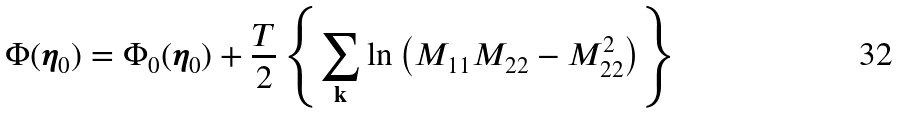Convert formula to latex. <formula><loc_0><loc_0><loc_500><loc_500>\Phi ( { \boldsymbol \eta } _ { 0 } ) = \Phi _ { 0 } ( { \boldsymbol \eta } _ { 0 } ) + { \frac { T } { 2 } } \left \{ { \sum _ { \mathbf k } } \ln \left ( M _ { 1 1 } M _ { 2 2 } - M _ { 2 2 } ^ { 2 } \right ) \right \}</formula> 